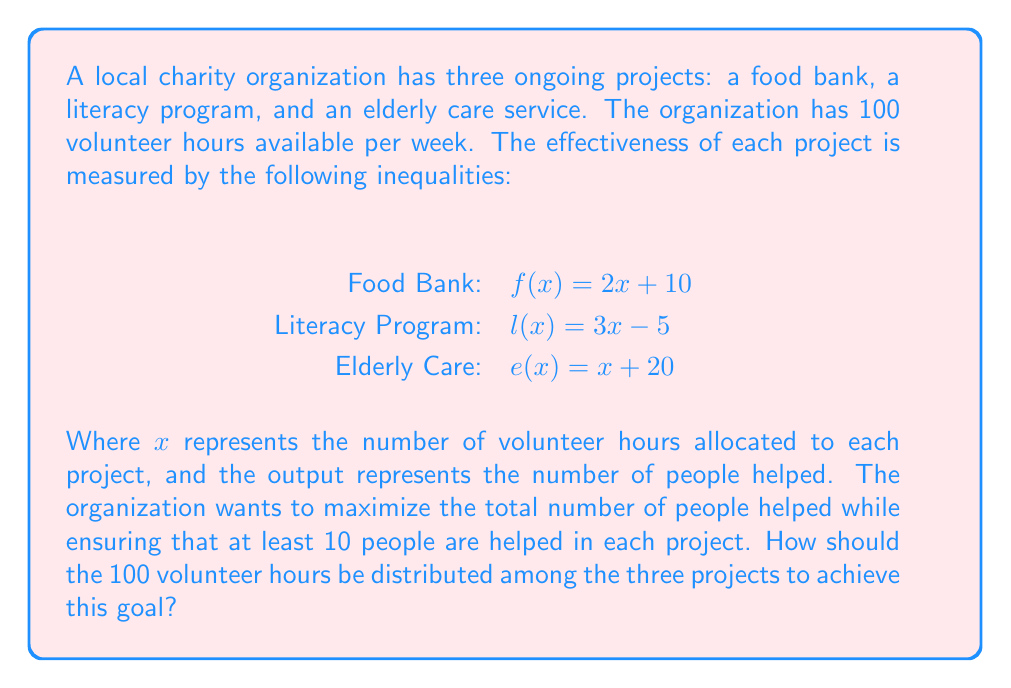Can you answer this question? 1. Set up the optimization problem:
   Maximize $Z = f(x_1) + l(x_2) + e(x_3)$
   Subject to constraints:
   $x_1 + x_2 + x_3 \leq 100$ (total available hours)
   $f(x_1) \geq 10$, $l(x_2) \geq 10$, $e(x_3) \geq 10$ (minimum people helped per project)
   $x_1, x_2, x_3 \geq 0$ (non-negative hours)

2. Solve the minimum requirements:
   Food Bank: $2x_1 + 10 \geq 10$ → $x_1 \geq 0$
   Literacy Program: $3x_2 - 5 \geq 10$ → $x_2 \geq 5$
   Elderly Care: $x_3 + 20 \geq 10$ → $x_3 \geq 0$

3. Compare the rates of increase:
   Food Bank: 2 people/hour
   Literacy Program: 3 people/hour
   Elderly Care: 1 person/hour

4. Optimal allocation strategy:
   - Allocate 5 hours to the Literacy Program to meet the minimum requirement.
   - Allocate the remaining 95 hours to the Literacy Program, as it has the highest rate of increase.

5. Calculate the results:
   Literacy Program: $l(100) = 3(100) - 5 = 295$ people helped
   Food Bank: $f(0) = 2(0) + 10 = 10$ people helped
   Elderly Care: $e(0) = 0 + 20 = 20$ people helped

6. Total people helped: $295 + 10 + 20 = 325$

Therefore, the optimal distribution is 0 hours for the Food Bank, 100 hours for the Literacy Program, and 0 hours for Elderly Care.
Answer: Food Bank: 0 hours, Literacy Program: 100 hours, Elderly Care: 0 hours 